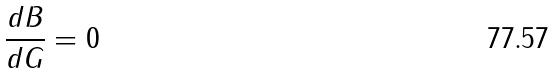<formula> <loc_0><loc_0><loc_500><loc_500>\frac { d B } { d G } = 0</formula> 